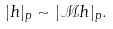Convert formula to latex. <formula><loc_0><loc_0><loc_500><loc_500>| h | _ { p } \sim | \mathcal { M } h | _ { p } .</formula> 